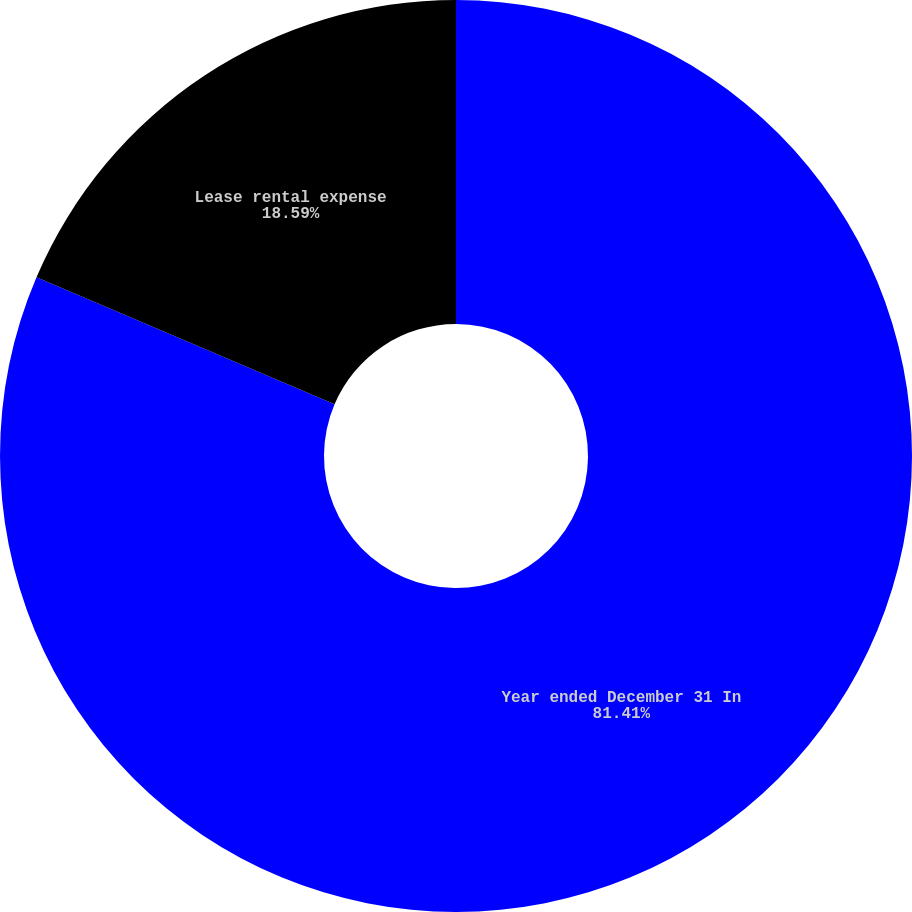<chart> <loc_0><loc_0><loc_500><loc_500><pie_chart><fcel>Year ended December 31 In<fcel>Lease rental expense<nl><fcel>81.41%<fcel>18.59%<nl></chart> 